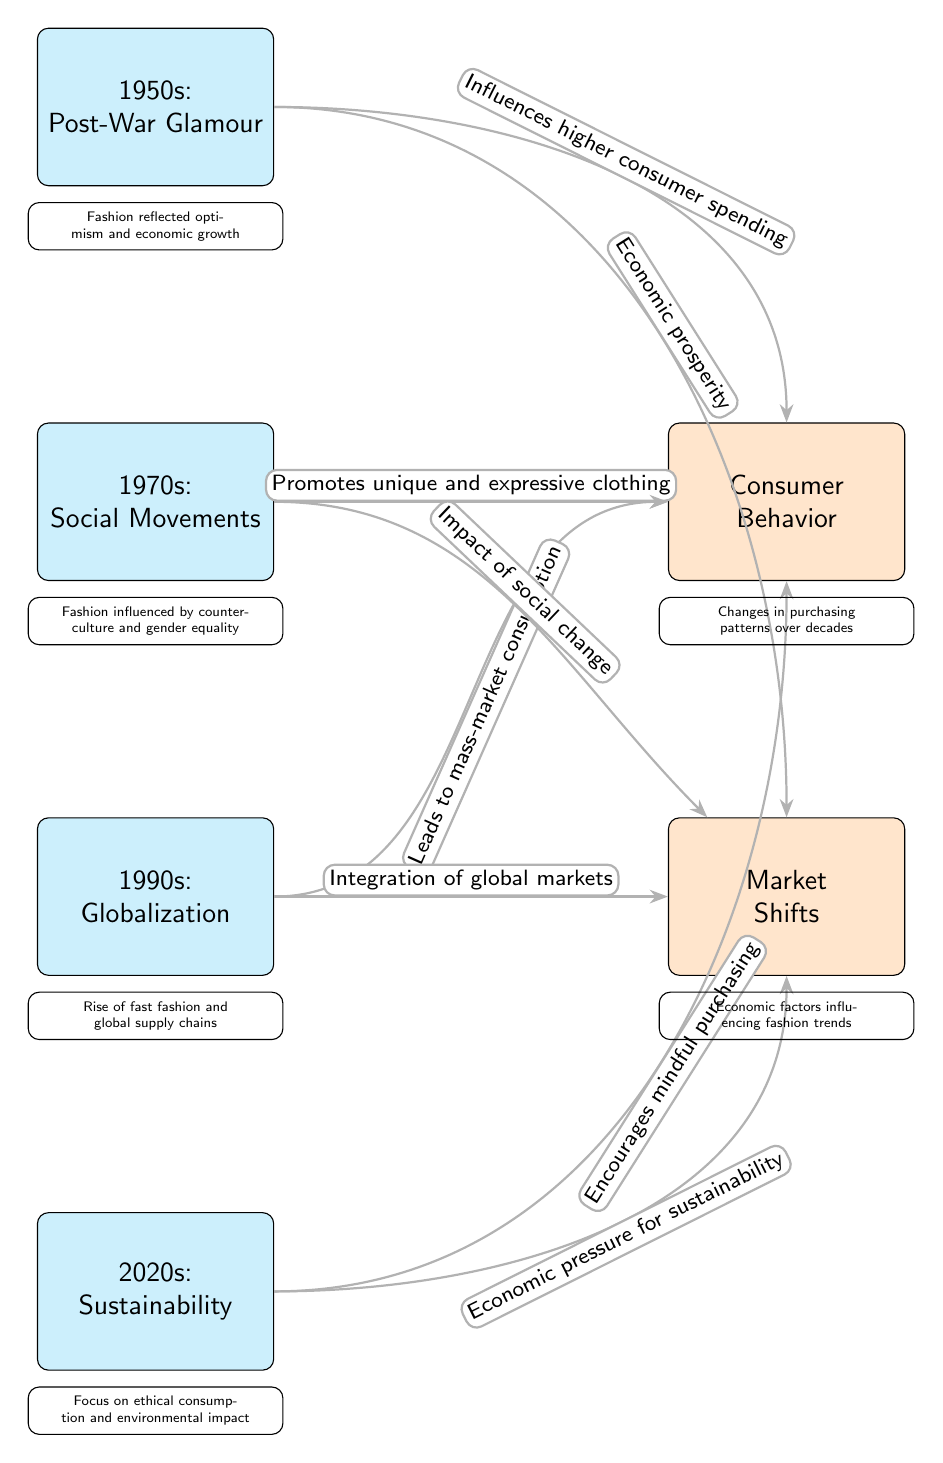What decade is associated with Post-War Glamour? The diagram directly shows that the 1950s is labeled with "Post-War Glamour."
Answer: 1950s What influence does the 1970s have on consumer behavior? The edge connecting the 1970 node to the consumer behavior factor explains that the 1970s promotes unique and expressive clothing.
Answer: Promotes unique and expressive clothing How many decades are represented in the diagram? By counting the nodes labeled as decades, we can see there are four: 1950s, 1970s, 1990s, and 2020s.
Answer: 4 What factor is linked to the 2020s? The 2020 node connects to both consumer behavior and market shifts. The relationship to consumer behavior mentions encouraging mindful purchasing.
Answer: Encourages mindful purchasing Which decade shows the impact of economic prosperity on market shifts? The 1950 node connects to the market shifts factor, noting economic prosperity.
Answer: 1950s What major trend associated with the 1990s is indicated for consumer behavior? The edge leading from the 1990 node to the consumer behavior factor states that it leads to mass-market consumption.
Answer: Leads to mass-market consumption Which socio-economic factor is highlighted for the 2020s regarding market shifts? The 2020 node has an edge pointing to market shifts, stating economic pressure for sustainability.
Answer: Economic pressure for sustainability Which factor is linked to social change according to the 1970s? The edge from the 1970 node to the market shifts mentions the "Impact of social change," indicating a direct link to that factor.
Answer: Impact of social change What descriptor follows the 1990s in the diagram? The diagram provides a specific descriptor underneath the 1990s stating the rise of fast fashion and global supply chains.
Answer: Rise of fast fashion and global supply chains 